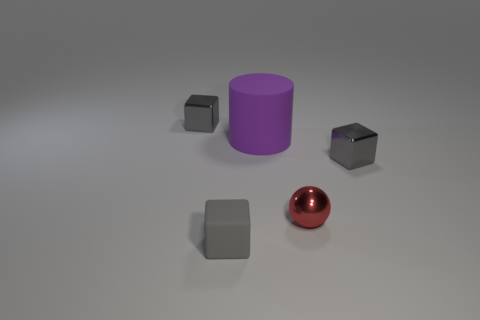Add 2 big cyan shiny spheres. How many objects exist? 7 Subtract all spheres. How many objects are left? 4 Subtract all small matte objects. Subtract all large metallic blocks. How many objects are left? 4 Add 2 large purple cylinders. How many large purple cylinders are left? 3 Add 1 gray things. How many gray things exist? 4 Subtract 0 brown cylinders. How many objects are left? 5 